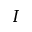<formula> <loc_0><loc_0><loc_500><loc_500>I</formula> 